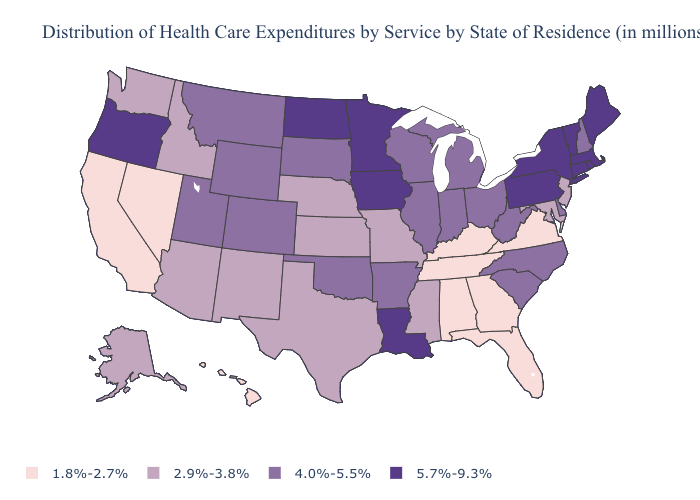Among the states that border Wisconsin , does Michigan have the highest value?
Short answer required. No. Name the states that have a value in the range 4.0%-5.5%?
Concise answer only. Arkansas, Colorado, Delaware, Illinois, Indiana, Michigan, Montana, New Hampshire, North Carolina, Ohio, Oklahoma, South Carolina, South Dakota, Utah, West Virginia, Wisconsin, Wyoming. Which states hav the highest value in the MidWest?
Quick response, please. Iowa, Minnesota, North Dakota. What is the highest value in the USA?
Concise answer only. 5.7%-9.3%. What is the highest value in the USA?
Keep it brief. 5.7%-9.3%. What is the value of Illinois?
Give a very brief answer. 4.0%-5.5%. What is the lowest value in the West?
Quick response, please. 1.8%-2.7%. Name the states that have a value in the range 1.8%-2.7%?
Write a very short answer. Alabama, California, Florida, Georgia, Hawaii, Kentucky, Nevada, Tennessee, Virginia. What is the lowest value in the USA?
Short answer required. 1.8%-2.7%. What is the value of Nevada?
Concise answer only. 1.8%-2.7%. What is the value of West Virginia?
Be succinct. 4.0%-5.5%. Name the states that have a value in the range 2.9%-3.8%?
Write a very short answer. Alaska, Arizona, Idaho, Kansas, Maryland, Mississippi, Missouri, Nebraska, New Jersey, New Mexico, Texas, Washington. What is the value of Rhode Island?
Keep it brief. 5.7%-9.3%. What is the value of Utah?
Write a very short answer. 4.0%-5.5%. What is the value of Louisiana?
Answer briefly. 5.7%-9.3%. 